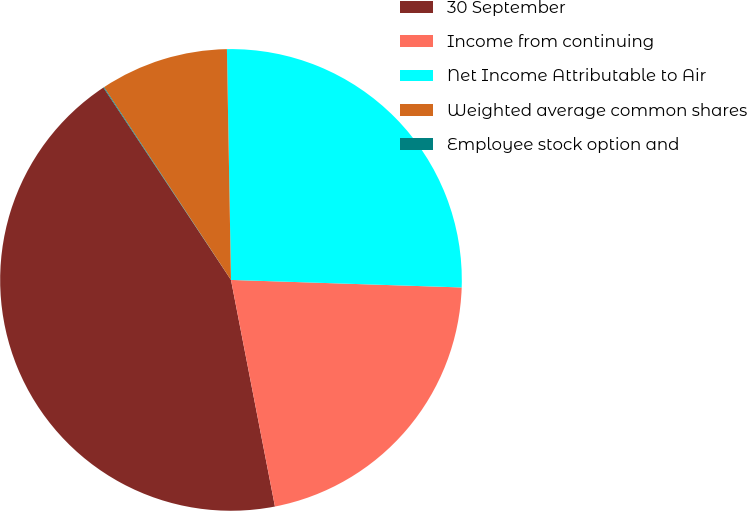<chart> <loc_0><loc_0><loc_500><loc_500><pie_chart><fcel>30 September<fcel>Income from continuing<fcel>Net Income Attributable to Air<fcel>Weighted average common shares<fcel>Employee stock option and<nl><fcel>43.73%<fcel>21.43%<fcel>25.8%<fcel>8.99%<fcel>0.05%<nl></chart> 